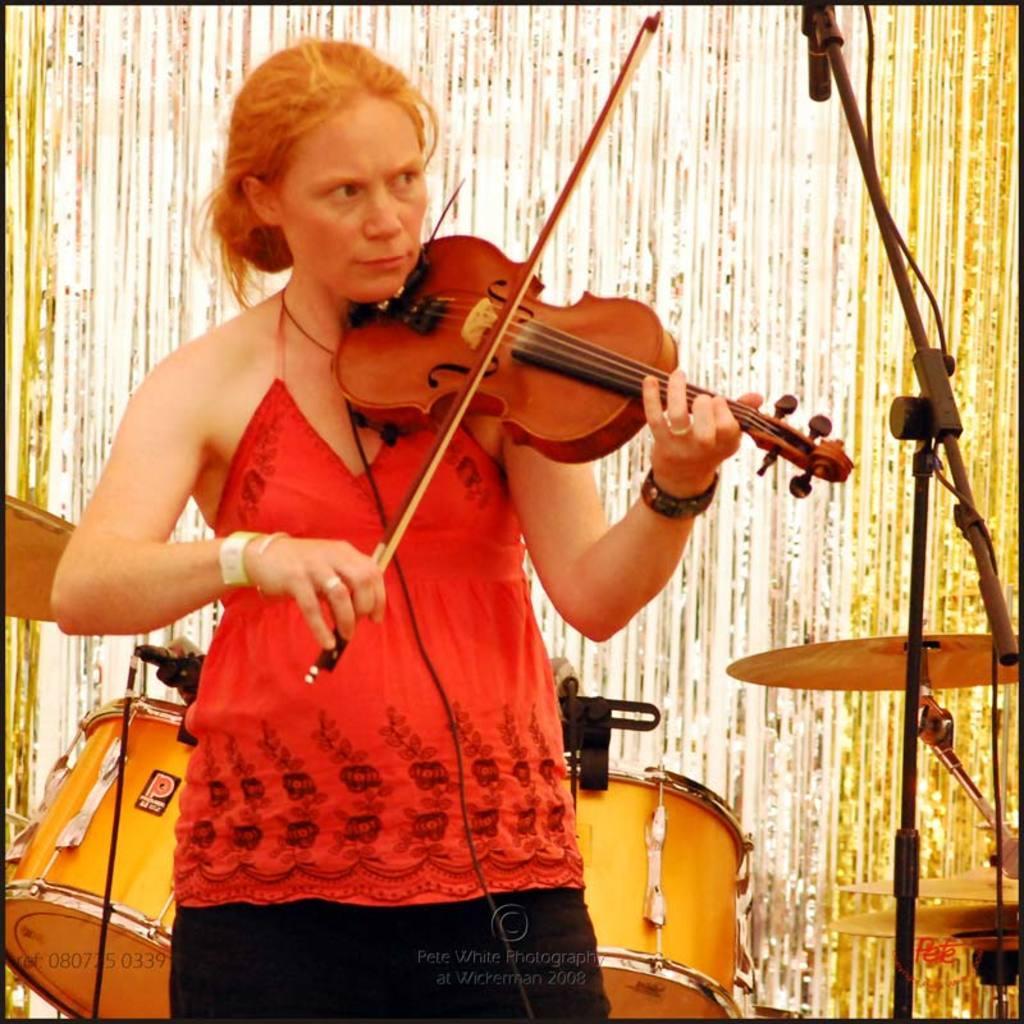In one or two sentences, can you explain what this image depicts? In the center of the image there is lady standing and playing a violin. There is a stand before her. In the background there is a band. 